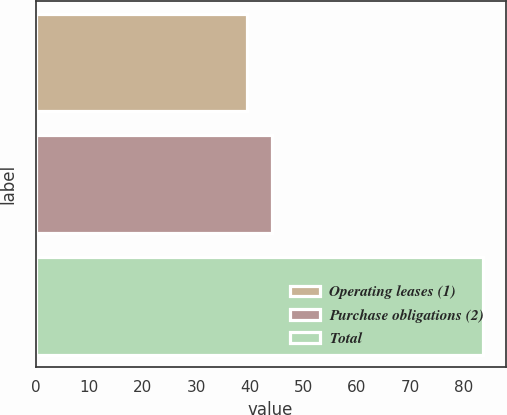Convert chart. <chart><loc_0><loc_0><loc_500><loc_500><bar_chart><fcel>Operating leases (1)<fcel>Purchase obligations (2)<fcel>Total<nl><fcel>39.4<fcel>44.2<fcel>83.6<nl></chart> 